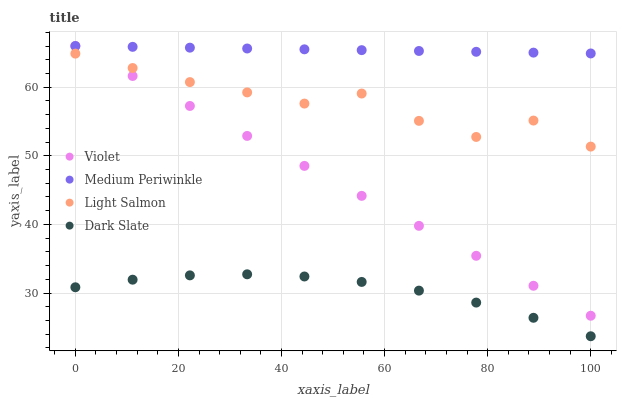Does Dark Slate have the minimum area under the curve?
Answer yes or no. Yes. Does Medium Periwinkle have the maximum area under the curve?
Answer yes or no. Yes. Does Light Salmon have the minimum area under the curve?
Answer yes or no. No. Does Light Salmon have the maximum area under the curve?
Answer yes or no. No. Is Violet the smoothest?
Answer yes or no. Yes. Is Light Salmon the roughest?
Answer yes or no. Yes. Is Medium Periwinkle the smoothest?
Answer yes or no. No. Is Medium Periwinkle the roughest?
Answer yes or no. No. Does Dark Slate have the lowest value?
Answer yes or no. Yes. Does Light Salmon have the lowest value?
Answer yes or no. No. Does Violet have the highest value?
Answer yes or no. Yes. Does Light Salmon have the highest value?
Answer yes or no. No. Is Dark Slate less than Violet?
Answer yes or no. Yes. Is Violet greater than Dark Slate?
Answer yes or no. Yes. Does Violet intersect Light Salmon?
Answer yes or no. Yes. Is Violet less than Light Salmon?
Answer yes or no. No. Is Violet greater than Light Salmon?
Answer yes or no. No. Does Dark Slate intersect Violet?
Answer yes or no. No. 